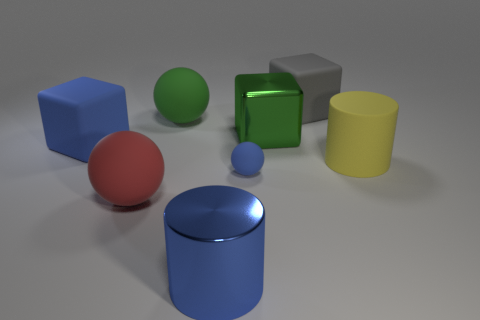Add 2 large yellow matte spheres. How many objects exist? 10 Subtract all matte cubes. How many cubes are left? 1 Subtract all balls. How many objects are left? 5 Subtract 1 blocks. How many blocks are left? 2 Subtract all blue spheres. How many spheres are left? 2 Subtract all blue shiny cylinders. Subtract all rubber spheres. How many objects are left? 4 Add 5 metallic things. How many metallic things are left? 7 Add 1 big metallic blocks. How many big metallic blocks exist? 2 Subtract 1 blue balls. How many objects are left? 7 Subtract all red cubes. Subtract all blue cylinders. How many cubes are left? 3 